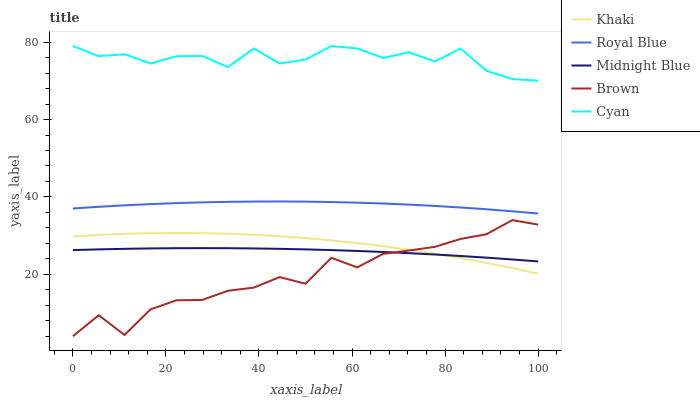Does Brown have the minimum area under the curve?
Answer yes or no. Yes. Does Cyan have the maximum area under the curve?
Answer yes or no. Yes. Does Khaki have the minimum area under the curve?
Answer yes or no. No. Does Khaki have the maximum area under the curve?
Answer yes or no. No. Is Midnight Blue the smoothest?
Answer yes or no. Yes. Is Brown the roughest?
Answer yes or no. Yes. Is Cyan the smoothest?
Answer yes or no. No. Is Cyan the roughest?
Answer yes or no. No. Does Brown have the lowest value?
Answer yes or no. Yes. Does Khaki have the lowest value?
Answer yes or no. No. Does Cyan have the highest value?
Answer yes or no. Yes. Does Khaki have the highest value?
Answer yes or no. No. Is Royal Blue less than Cyan?
Answer yes or no. Yes. Is Royal Blue greater than Khaki?
Answer yes or no. Yes. Does Khaki intersect Brown?
Answer yes or no. Yes. Is Khaki less than Brown?
Answer yes or no. No. Is Khaki greater than Brown?
Answer yes or no. No. Does Royal Blue intersect Cyan?
Answer yes or no. No. 